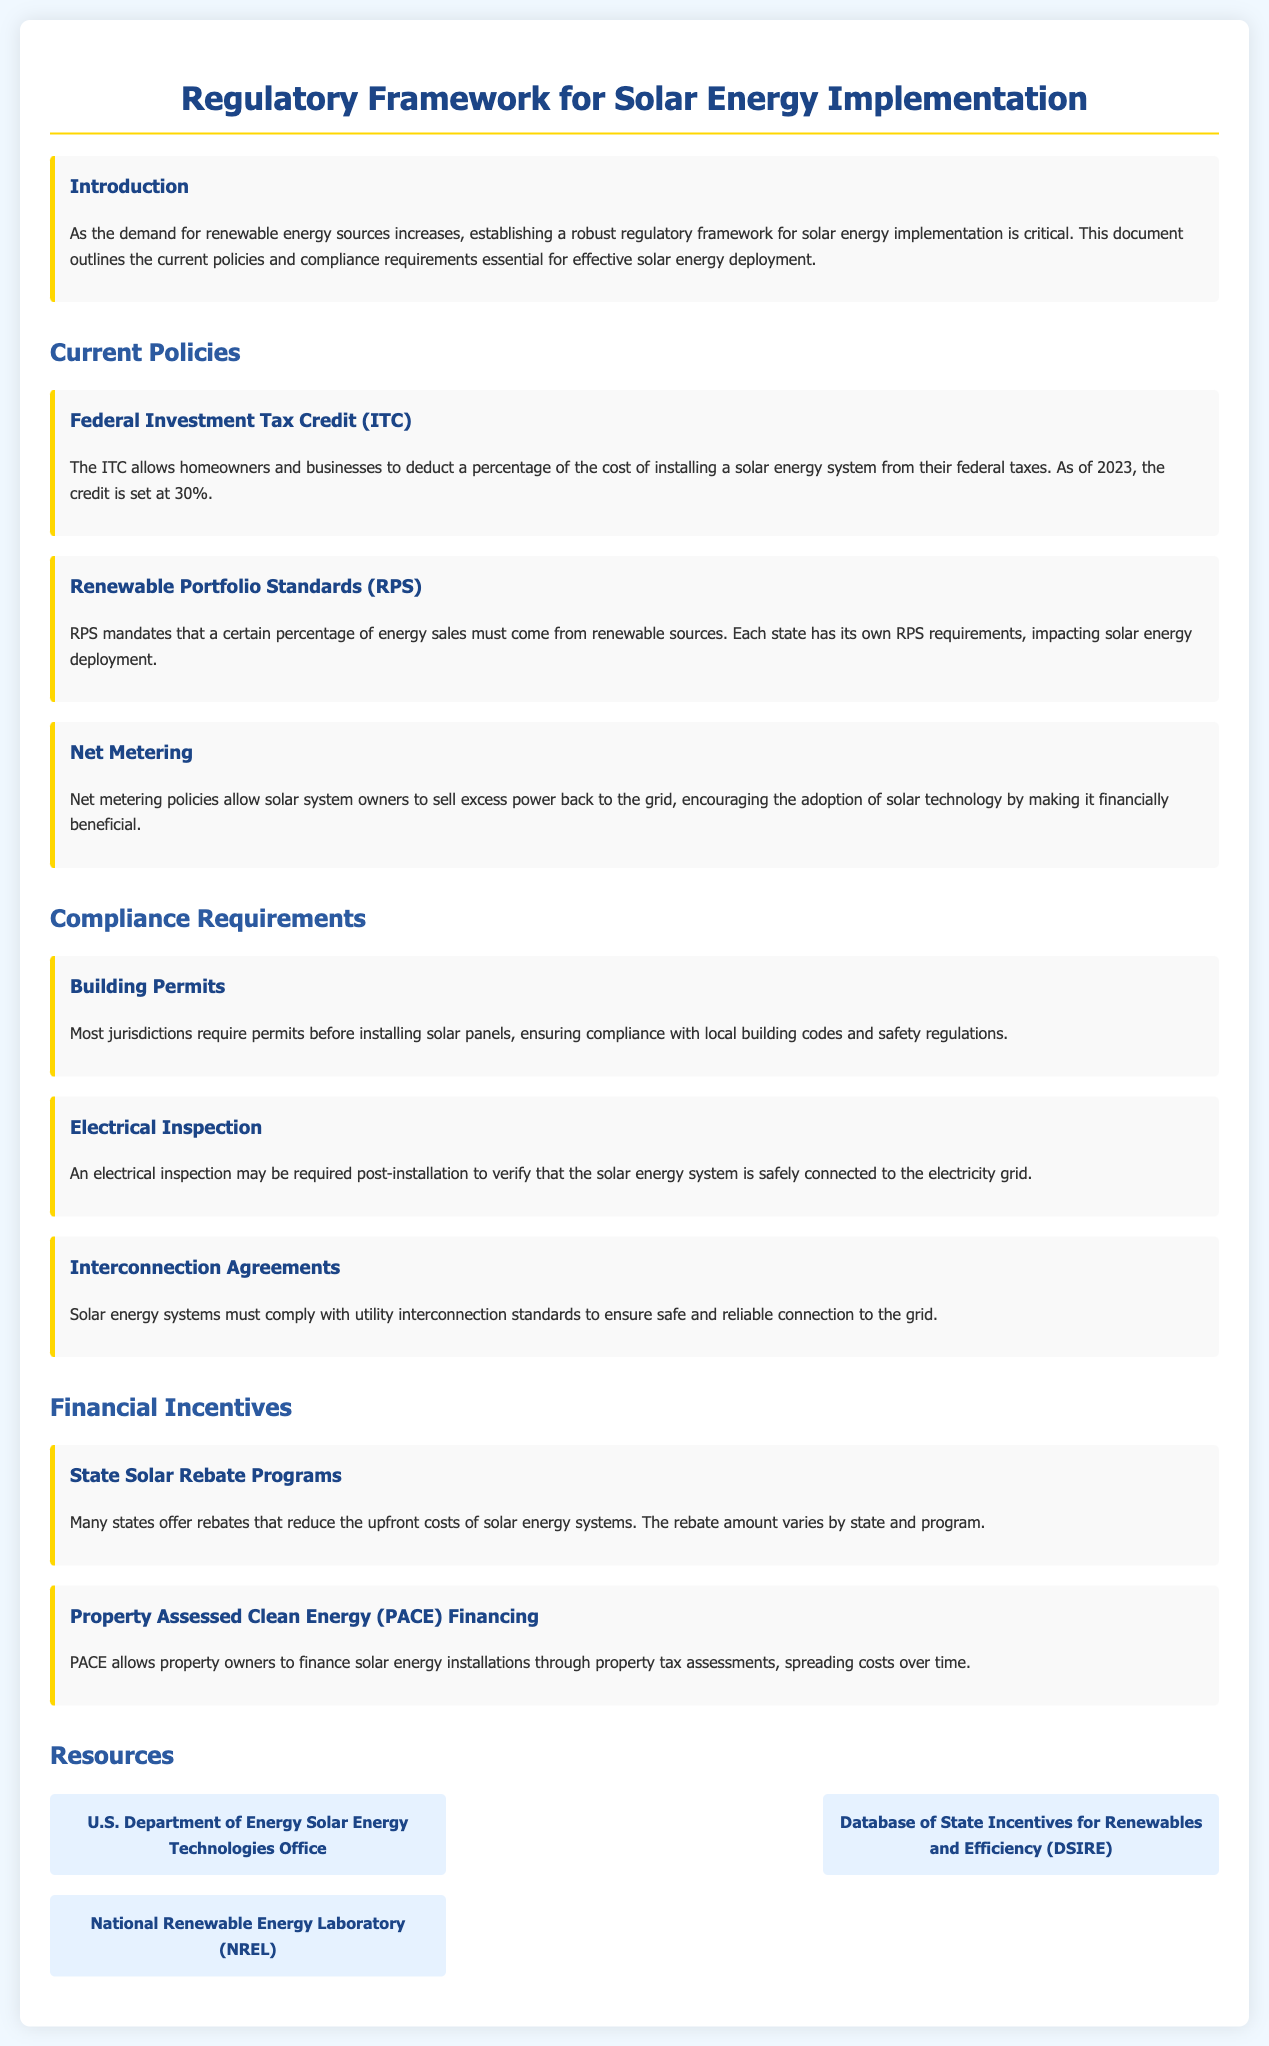What is the percentage of the Federal Investment Tax Credit as of 2023? The Federal Investment Tax Credit is set at 30% as of 2023.
Answer: 30% What do Renewable Portfolio Standards (RPS) mandate? RPS mandates that a certain percentage of energy sales must come from renewable sources.
Answer: Percentage of energy sales What is required before installing solar panels in most jurisdictions? Most jurisdictions require permits before installing solar panels.
Answer: Permits What is the purpose of net metering policies? Net metering policies allow solar system owners to sell excess power back to the grid.
Answer: Sell excess power What does PACE financing allow property owners to do? PACE allows property owners to finance solar energy installations through property tax assessments.
Answer: Finance installations What is the role of interconnection agreements in solar energy systems? Solar energy systems must comply with utility interconnection standards to ensure safe and reliable connection to the grid.
Answer: Compliance with utility standards Name a source for state incentive information for renewables. The Database of State Incentives for Renewables and Efficiency (DSIRE) is one source.
Answer: DSIRE Which office oversees the U.S. Department of Energy Solar Energy Technologies? The U.S. Department of Energy oversees the Solar Energy Technologies Office.
Answer: U.S. Department of Energy What type of inspection may be required after solar energy system installation? An electrical inspection may be required post-installation.
Answer: Electrical inspection 